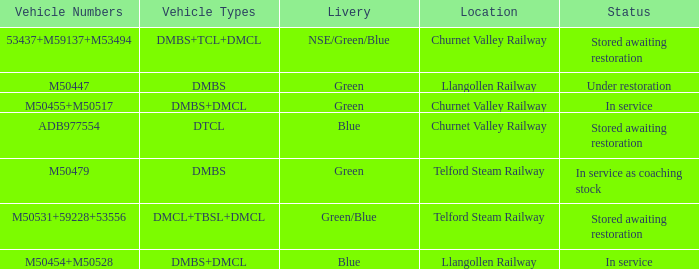What status is the vehicle types of dmbs+tcl+dmcl? Stored awaiting restoration. Parse the table in full. {'header': ['Vehicle Numbers', 'Vehicle Types', 'Livery', 'Location', 'Status'], 'rows': [['53437+M59137+M53494', 'DMBS+TCL+DMCL', 'NSE/Green/Blue', 'Churnet Valley Railway', 'Stored awaiting restoration'], ['M50447', 'DMBS', 'Green', 'Llangollen Railway', 'Under restoration'], ['M50455+M50517', 'DMBS+DMCL', 'Green', 'Churnet Valley Railway', 'In service'], ['ADB977554', 'DTCL', 'Blue', 'Churnet Valley Railway', 'Stored awaiting restoration'], ['M50479', 'DMBS', 'Green', 'Telford Steam Railway', 'In service as coaching stock'], ['M50531+59228+53556', 'DMCL+TBSL+DMCL', 'Green/Blue', 'Telford Steam Railway', 'Stored awaiting restoration'], ['M50454+M50528', 'DMBS+DMCL', 'Blue', 'Llangollen Railway', 'In service']]} 